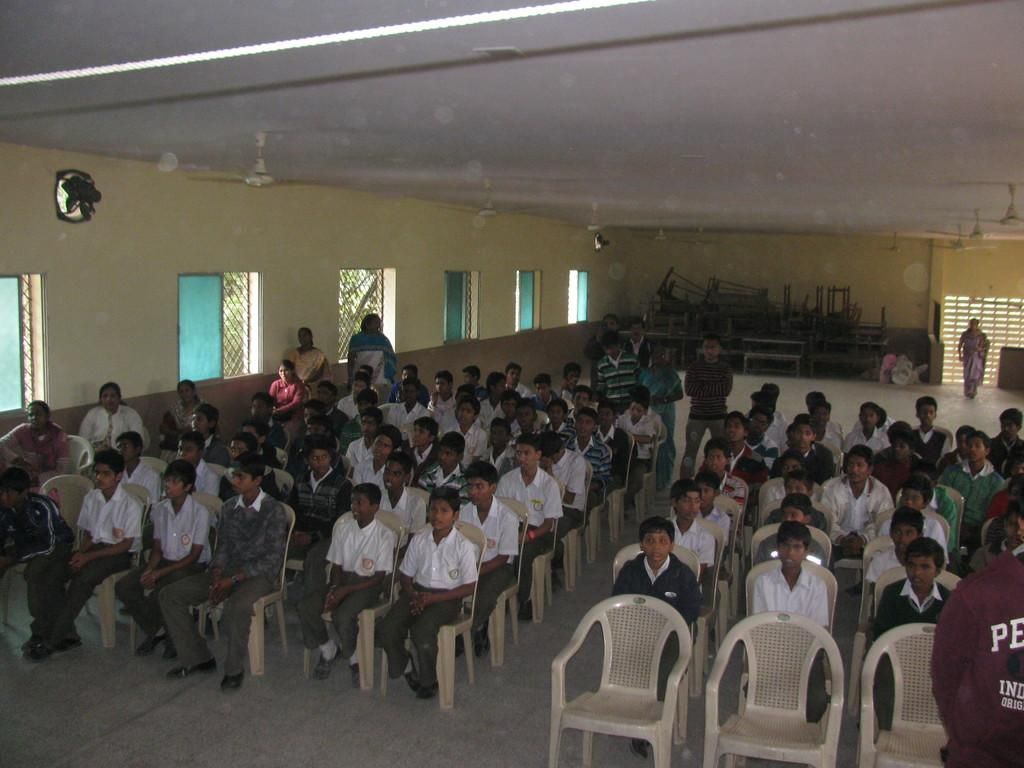What are the people in the image doing? There are persons sitting on chairs in the image. What can be seen beneath the people in the image? There is a floor visible in the image. What type of furniture is present in the background of the image? There are benches in the background of the image. What architectural features can be seen in the background of the image? There is a wall and windows in the background of the image. What type of game is being played by the strangers in the image? There are no strangers or games present in the image; it features persons sitting on chairs and other elements mentioned in the facts. 